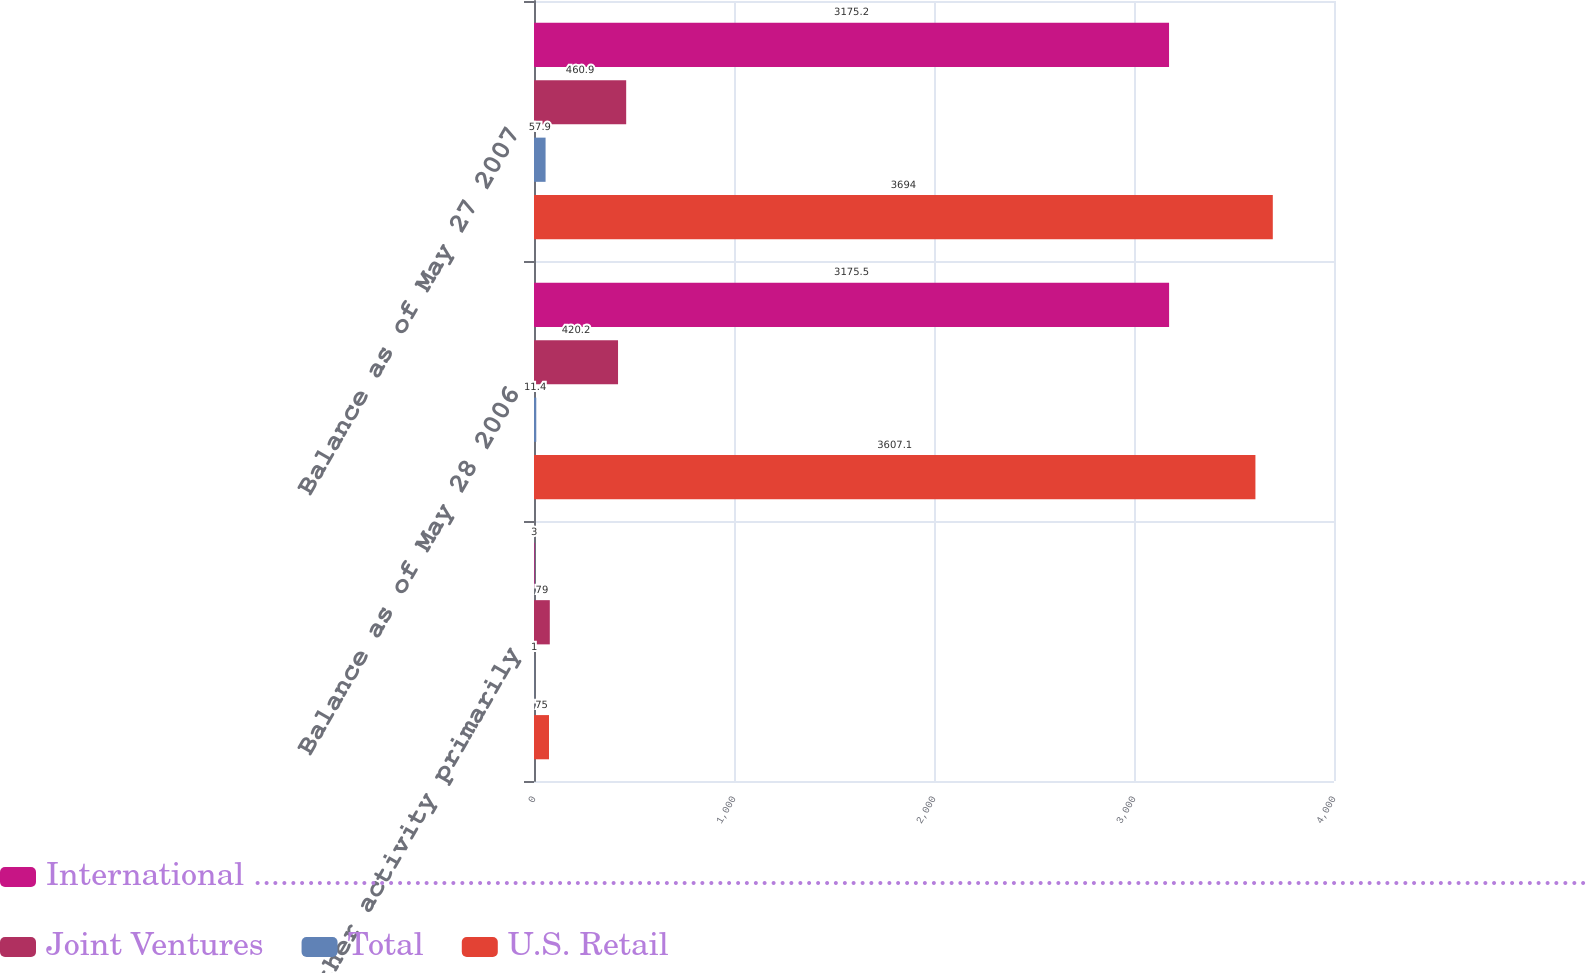<chart> <loc_0><loc_0><loc_500><loc_500><stacked_bar_chart><ecel><fcel>Other activity primarily<fcel>Balance as of May 28 2006<fcel>Balance as of May 27 2007<nl><fcel>International .........................................................................................................................................................................................<fcel>3<fcel>3175.5<fcel>3175.2<nl><fcel>Joint Ventures<fcel>79<fcel>420.2<fcel>460.9<nl><fcel>Total<fcel>1<fcel>11.4<fcel>57.9<nl><fcel>U.S. Retail<fcel>75<fcel>3607.1<fcel>3694<nl></chart> 